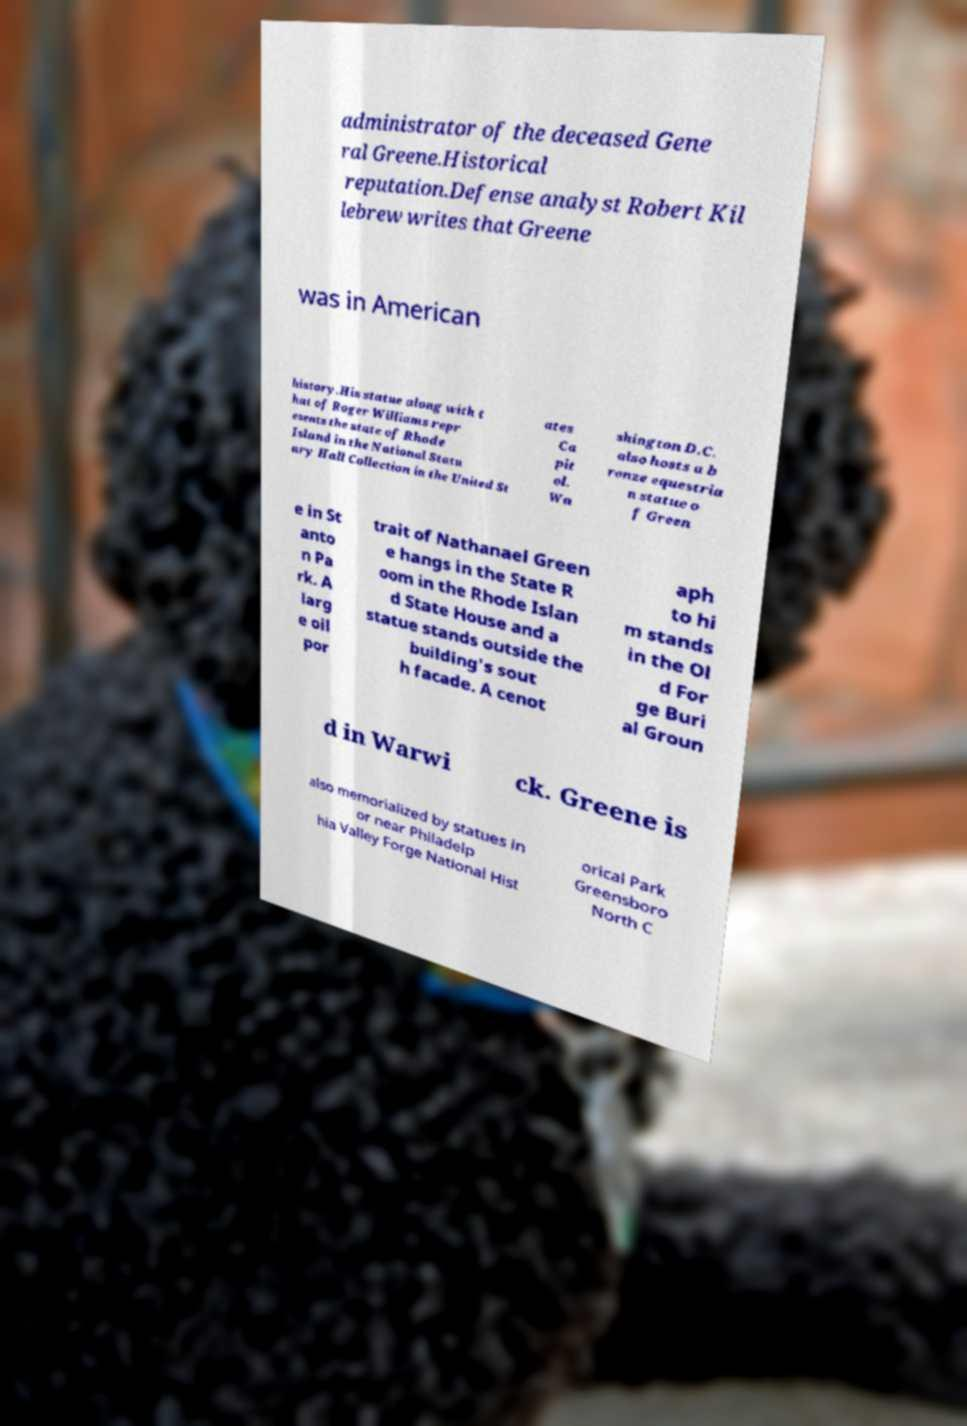Could you extract and type out the text from this image? administrator of the deceased Gene ral Greene.Historical reputation.Defense analyst Robert Kil lebrew writes that Greene was in American history.His statue along with t hat of Roger Williams repr esents the state of Rhode Island in the National Statu ary Hall Collection in the United St ates Ca pit ol. Wa shington D.C. also hosts a b ronze equestria n statue o f Green e in St anto n Pa rk. A larg e oil por trait of Nathanael Green e hangs in the State R oom in the Rhode Islan d State House and a statue stands outside the building's sout h facade. A cenot aph to hi m stands in the Ol d For ge Buri al Groun d in Warwi ck. Greene is also memorialized by statues in or near Philadelp hia Valley Forge National Hist orical Park Greensboro North C 